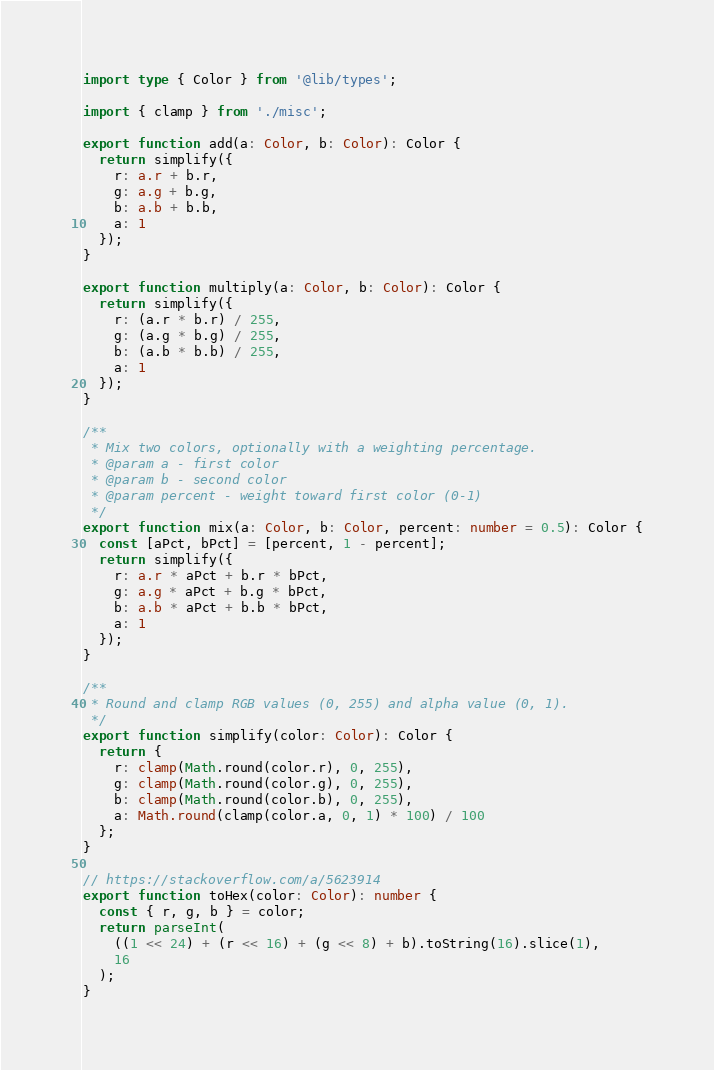Convert code to text. <code><loc_0><loc_0><loc_500><loc_500><_TypeScript_>import type { Color } from '@lib/types';

import { clamp } from './misc';

export function add(a: Color, b: Color): Color {
  return simplify({
    r: a.r + b.r,
    g: a.g + b.g,
    b: a.b + b.b,
    a: 1
  });
}

export function multiply(a: Color, b: Color): Color {
  return simplify({
    r: (a.r * b.r) / 255,
    g: (a.g * b.g) / 255,
    b: (a.b * b.b) / 255,
    a: 1
  });
}

/**
 * Mix two colors, optionally with a weighting percentage.
 * @param a - first color
 * @param b - second color
 * @param percent - weight toward first color (0-1)
 */
export function mix(a: Color, b: Color, percent: number = 0.5): Color {
  const [aPct, bPct] = [percent, 1 - percent];
  return simplify({
    r: a.r * aPct + b.r * bPct,
    g: a.g * aPct + b.g * bPct,
    b: a.b * aPct + b.b * bPct,
    a: 1
  });
}

/**
 * Round and clamp RGB values (0, 255) and alpha value (0, 1).
 */
export function simplify(color: Color): Color {
  return {
    r: clamp(Math.round(color.r), 0, 255),
    g: clamp(Math.round(color.g), 0, 255),
    b: clamp(Math.round(color.b), 0, 255),
    a: Math.round(clamp(color.a, 0, 1) * 100) / 100
  };
}

// https://stackoverflow.com/a/5623914
export function toHex(color: Color): number {
  const { r, g, b } = color;
  return parseInt(
    ((1 << 24) + (r << 16) + (g << 8) + b).toString(16).slice(1),
    16
  );
}
</code> 